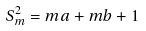<formula> <loc_0><loc_0><loc_500><loc_500>S _ { m } ^ { 2 } = m a + m b + 1</formula> 